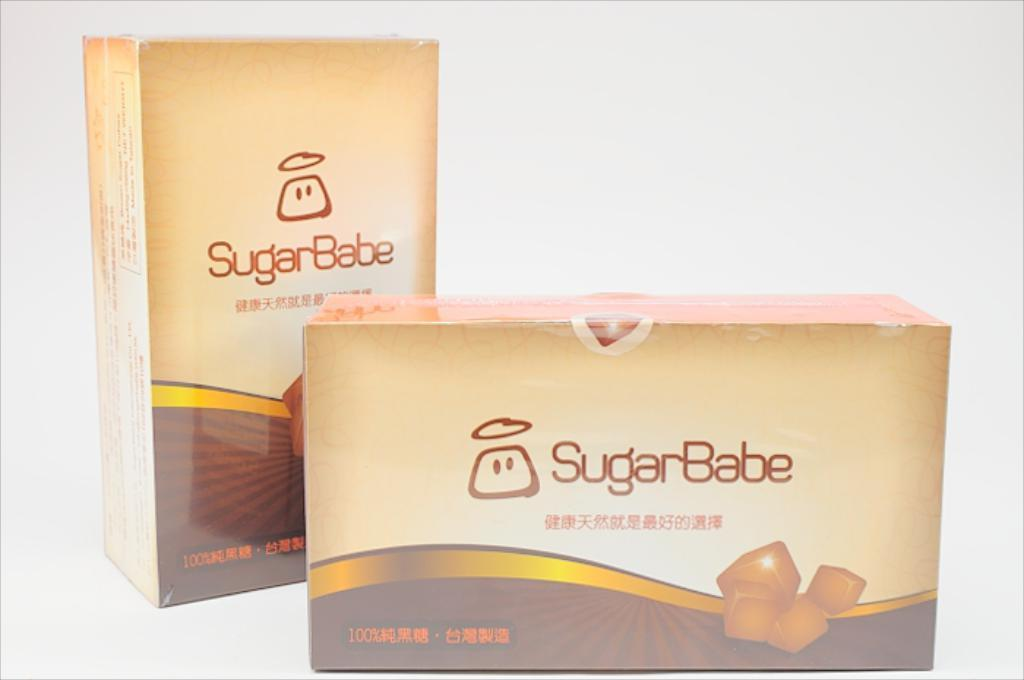<image>
Summarize the visual content of the image. A box of candy is called Sugar Babe. 